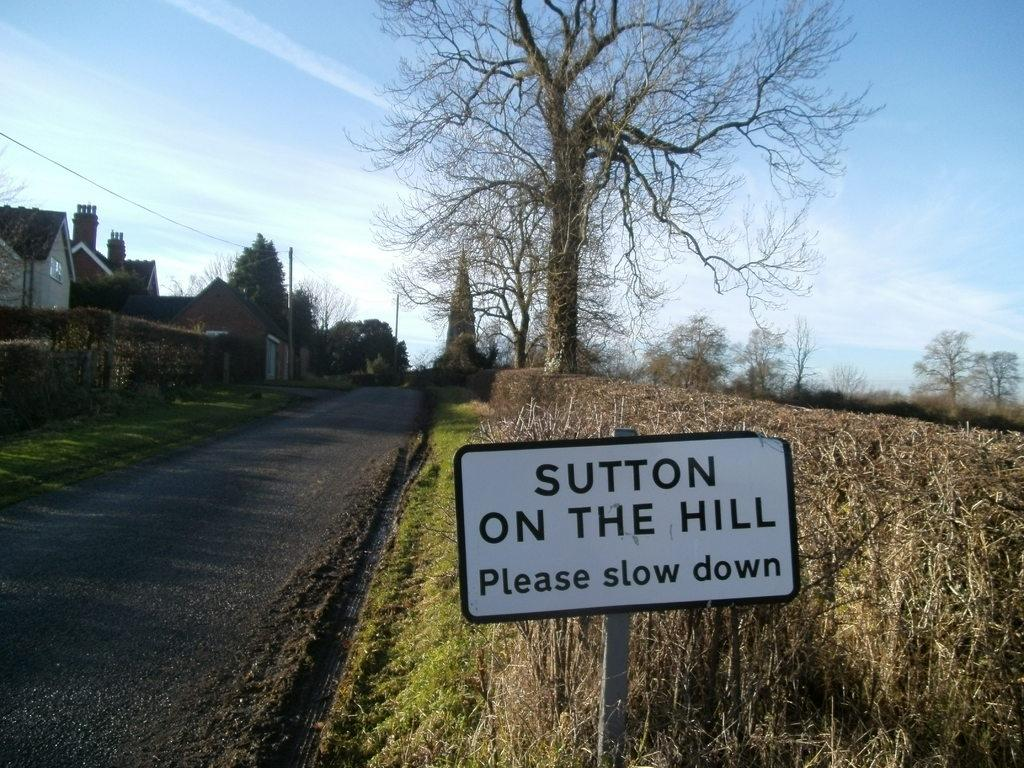What is the main object in the image? There is a sign board in the image. What type of vegetation can be seen in the image? Bushes and trees are visible in the image. What type of structures are present in the image? Buildings and fences are present in the image. What is used for transmitting electricity in the image? Electric poles and cables are present in the image. What is the surface on which vehicles might travel in the image? There is a road in the image. What is visible in the sky in the image? The sky is visible in the image, and clouds are present. What word is being spelled out by the group of people taking a bath in the image? There is no group of people taking a bath in the image, and therefore no word can be spelled out by them. 